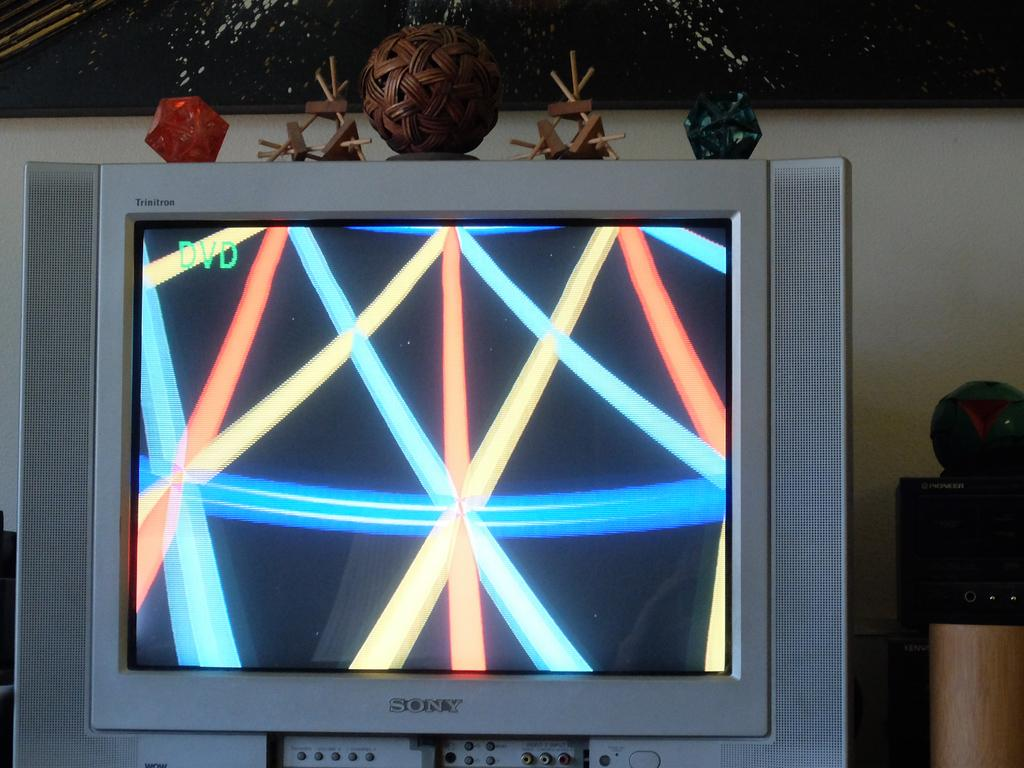<image>
Summarize the visual content of the image. Sony silver flat screen television with lines on the screen 